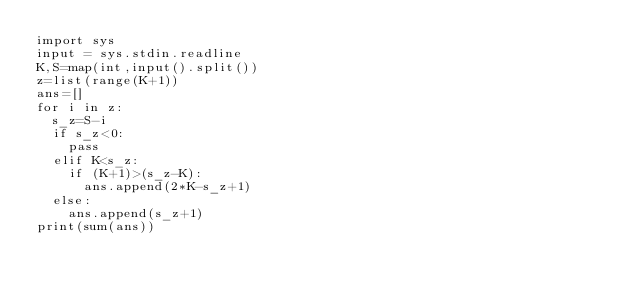<code> <loc_0><loc_0><loc_500><loc_500><_Python_>import sys
input = sys.stdin.readline
K,S=map(int,input().split())
z=list(range(K+1))
ans=[]
for i in z:
  s_z=S-i
  if s_z<0:
    pass
  elif K<s_z:
    if (K+1)>(s_z-K):
      ans.append(2*K-s_z+1)
  else:
    ans.append(s_z+1)
print(sum(ans))</code> 